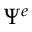<formula> <loc_0><loc_0><loc_500><loc_500>\Psi ^ { e }</formula> 